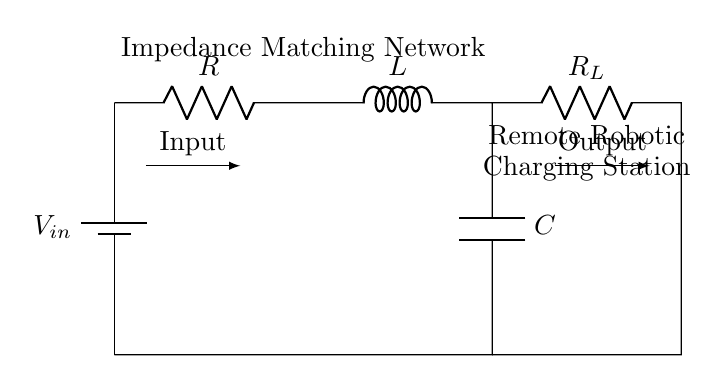What type of components are used in this circuit? The circuit consists of a resistor, an inductor, and a capacitor, commonly referred to as an RLC circuit.
Answer: Resistor, Inductor, Capacitor What is the purpose of this RLC network? The RLC network is designed for impedance matching to ensure efficient power transfer from the power source to the load in a remote robotic charging station.
Answer: Impedance matching How many resistors are present in the circuit? There are two resistors in the circuit: one for the impedance matching network and another for the load.
Answer: Two What is the configuration of the R, L, and C components? The components are arranged in series: the resistor first, followed by the inductor, and then the capacitor.
Answer: Series Why is impedance matching important in this circuit? Impedance matching is crucial to maximize power transfer and minimize reflections between the source and the load, improving overall efficiency in charging robotic systems.
Answer: To maximize power transfer What is the load connected to in this circuit? The load is connected to an additional resistor labeled as R_L, which represents the load that is being powered via the RLC network.
Answer: R_L What might happen if the impedance is not matched? Without proper impedance matching, there could be significant power losses, leading to inefficient operation of the charging station and potential damage to the components.
Answer: Power losses 